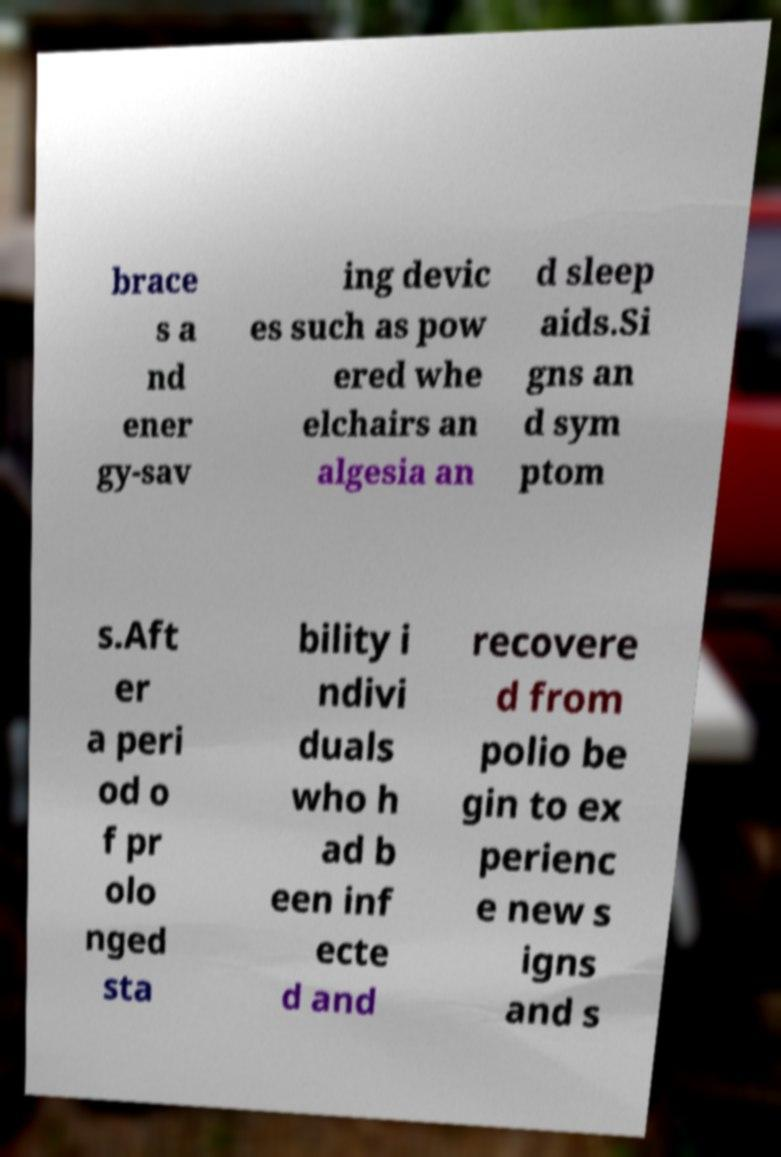What messages or text are displayed in this image? I need them in a readable, typed format. brace s a nd ener gy-sav ing devic es such as pow ered whe elchairs an algesia an d sleep aids.Si gns an d sym ptom s.Aft er a peri od o f pr olo nged sta bility i ndivi duals who h ad b een inf ecte d and recovere d from polio be gin to ex perienc e new s igns and s 